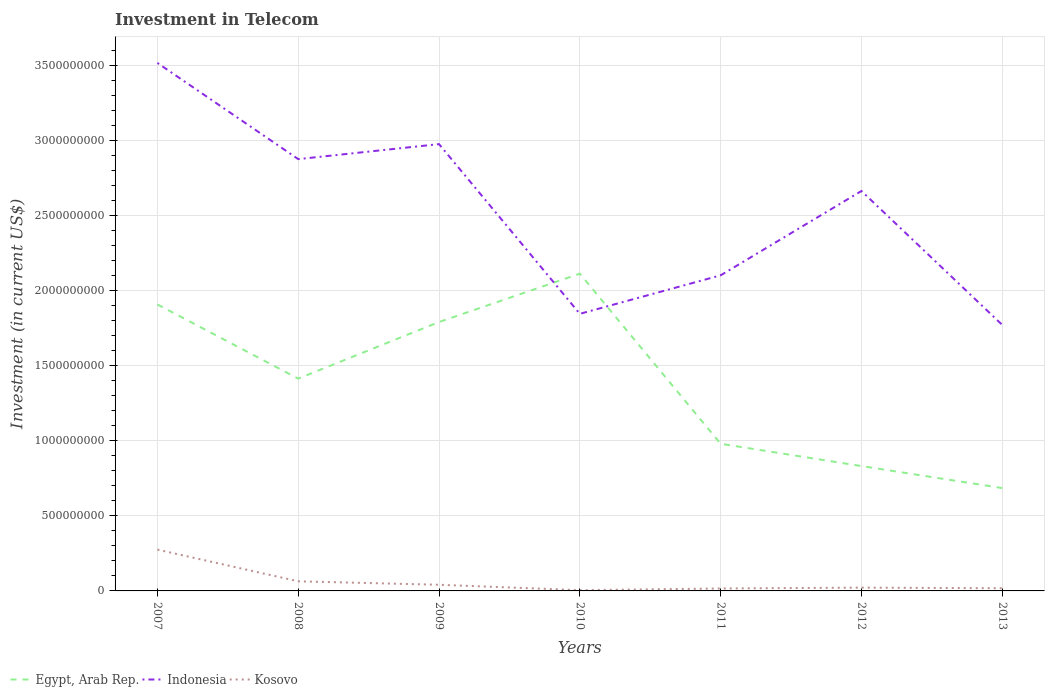Does the line corresponding to Egypt, Arab Rep. intersect with the line corresponding to Indonesia?
Ensure brevity in your answer.  Yes. Is the number of lines equal to the number of legend labels?
Provide a short and direct response. Yes. Across all years, what is the maximum amount invested in telecom in Indonesia?
Offer a very short reply. 1.77e+09. What is the total amount invested in telecom in Egypt, Arab Rep. in the graph?
Keep it short and to the point. 1.13e+09. What is the difference between the highest and the second highest amount invested in telecom in Kosovo?
Your answer should be compact. 2.70e+08. What is the difference between the highest and the lowest amount invested in telecom in Indonesia?
Provide a succinct answer. 4. How many lines are there?
Provide a short and direct response. 3. How many years are there in the graph?
Provide a succinct answer. 7. Are the values on the major ticks of Y-axis written in scientific E-notation?
Your answer should be compact. No. Does the graph contain any zero values?
Keep it short and to the point. No. Does the graph contain grids?
Offer a terse response. Yes. How are the legend labels stacked?
Your answer should be very brief. Horizontal. What is the title of the graph?
Ensure brevity in your answer.  Investment in Telecom. What is the label or title of the Y-axis?
Keep it short and to the point. Investment (in current US$). What is the Investment (in current US$) in Egypt, Arab Rep. in 2007?
Offer a very short reply. 1.91e+09. What is the Investment (in current US$) in Indonesia in 2007?
Provide a short and direct response. 3.52e+09. What is the Investment (in current US$) of Kosovo in 2007?
Ensure brevity in your answer.  2.75e+08. What is the Investment (in current US$) in Egypt, Arab Rep. in 2008?
Provide a short and direct response. 1.41e+09. What is the Investment (in current US$) of Indonesia in 2008?
Your answer should be very brief. 2.88e+09. What is the Investment (in current US$) in Kosovo in 2008?
Make the answer very short. 6.40e+07. What is the Investment (in current US$) in Egypt, Arab Rep. in 2009?
Offer a very short reply. 1.79e+09. What is the Investment (in current US$) of Indonesia in 2009?
Keep it short and to the point. 2.98e+09. What is the Investment (in current US$) of Kosovo in 2009?
Your response must be concise. 4.10e+07. What is the Investment (in current US$) in Egypt, Arab Rep. in 2010?
Ensure brevity in your answer.  2.11e+09. What is the Investment (in current US$) of Indonesia in 2010?
Give a very brief answer. 1.85e+09. What is the Investment (in current US$) of Kosovo in 2010?
Your answer should be compact. 5.10e+06. What is the Investment (in current US$) in Egypt, Arab Rep. in 2011?
Your answer should be very brief. 9.80e+08. What is the Investment (in current US$) in Indonesia in 2011?
Ensure brevity in your answer.  2.10e+09. What is the Investment (in current US$) of Kosovo in 2011?
Provide a succinct answer. 1.62e+07. What is the Investment (in current US$) in Egypt, Arab Rep. in 2012?
Keep it short and to the point. 8.32e+08. What is the Investment (in current US$) in Indonesia in 2012?
Offer a terse response. 2.66e+09. What is the Investment (in current US$) in Kosovo in 2012?
Make the answer very short. 2.20e+07. What is the Investment (in current US$) of Egypt, Arab Rep. in 2013?
Your answer should be compact. 6.85e+08. What is the Investment (in current US$) in Indonesia in 2013?
Ensure brevity in your answer.  1.77e+09. What is the Investment (in current US$) of Kosovo in 2013?
Give a very brief answer. 1.78e+07. Across all years, what is the maximum Investment (in current US$) in Egypt, Arab Rep.?
Provide a short and direct response. 2.11e+09. Across all years, what is the maximum Investment (in current US$) in Indonesia?
Provide a short and direct response. 3.52e+09. Across all years, what is the maximum Investment (in current US$) of Kosovo?
Make the answer very short. 2.75e+08. Across all years, what is the minimum Investment (in current US$) of Egypt, Arab Rep.?
Give a very brief answer. 6.85e+08. Across all years, what is the minimum Investment (in current US$) of Indonesia?
Your answer should be compact. 1.77e+09. Across all years, what is the minimum Investment (in current US$) of Kosovo?
Ensure brevity in your answer.  5.10e+06. What is the total Investment (in current US$) in Egypt, Arab Rep. in the graph?
Provide a succinct answer. 9.72e+09. What is the total Investment (in current US$) in Indonesia in the graph?
Provide a short and direct response. 1.78e+1. What is the total Investment (in current US$) of Kosovo in the graph?
Provide a short and direct response. 4.41e+08. What is the difference between the Investment (in current US$) of Egypt, Arab Rep. in 2007 and that in 2008?
Ensure brevity in your answer.  4.94e+08. What is the difference between the Investment (in current US$) of Indonesia in 2007 and that in 2008?
Your answer should be very brief. 6.41e+08. What is the difference between the Investment (in current US$) of Kosovo in 2007 and that in 2008?
Offer a very short reply. 2.11e+08. What is the difference between the Investment (in current US$) in Egypt, Arab Rep. in 2007 and that in 2009?
Your response must be concise. 1.17e+08. What is the difference between the Investment (in current US$) in Indonesia in 2007 and that in 2009?
Your response must be concise. 5.41e+08. What is the difference between the Investment (in current US$) of Kosovo in 2007 and that in 2009?
Your answer should be very brief. 2.34e+08. What is the difference between the Investment (in current US$) in Egypt, Arab Rep. in 2007 and that in 2010?
Make the answer very short. -2.05e+08. What is the difference between the Investment (in current US$) in Indonesia in 2007 and that in 2010?
Give a very brief answer. 1.67e+09. What is the difference between the Investment (in current US$) of Kosovo in 2007 and that in 2010?
Offer a terse response. 2.70e+08. What is the difference between the Investment (in current US$) of Egypt, Arab Rep. in 2007 and that in 2011?
Make the answer very short. 9.28e+08. What is the difference between the Investment (in current US$) in Indonesia in 2007 and that in 2011?
Make the answer very short. 1.41e+09. What is the difference between the Investment (in current US$) in Kosovo in 2007 and that in 2011?
Your response must be concise. 2.59e+08. What is the difference between the Investment (in current US$) of Egypt, Arab Rep. in 2007 and that in 2012?
Provide a succinct answer. 1.08e+09. What is the difference between the Investment (in current US$) of Indonesia in 2007 and that in 2012?
Provide a short and direct response. 8.53e+08. What is the difference between the Investment (in current US$) in Kosovo in 2007 and that in 2012?
Give a very brief answer. 2.53e+08. What is the difference between the Investment (in current US$) in Egypt, Arab Rep. in 2007 and that in 2013?
Offer a very short reply. 1.22e+09. What is the difference between the Investment (in current US$) in Indonesia in 2007 and that in 2013?
Provide a succinct answer. 1.74e+09. What is the difference between the Investment (in current US$) in Kosovo in 2007 and that in 2013?
Your response must be concise. 2.57e+08. What is the difference between the Investment (in current US$) of Egypt, Arab Rep. in 2008 and that in 2009?
Make the answer very short. -3.77e+08. What is the difference between the Investment (in current US$) in Indonesia in 2008 and that in 2009?
Make the answer very short. -9.99e+07. What is the difference between the Investment (in current US$) of Kosovo in 2008 and that in 2009?
Provide a short and direct response. 2.30e+07. What is the difference between the Investment (in current US$) in Egypt, Arab Rep. in 2008 and that in 2010?
Give a very brief answer. -6.99e+08. What is the difference between the Investment (in current US$) of Indonesia in 2008 and that in 2010?
Your answer should be compact. 1.03e+09. What is the difference between the Investment (in current US$) in Kosovo in 2008 and that in 2010?
Your answer should be very brief. 5.89e+07. What is the difference between the Investment (in current US$) in Egypt, Arab Rep. in 2008 and that in 2011?
Ensure brevity in your answer.  4.34e+08. What is the difference between the Investment (in current US$) in Indonesia in 2008 and that in 2011?
Offer a very short reply. 7.74e+08. What is the difference between the Investment (in current US$) of Kosovo in 2008 and that in 2011?
Ensure brevity in your answer.  4.78e+07. What is the difference between the Investment (in current US$) of Egypt, Arab Rep. in 2008 and that in 2012?
Your answer should be very brief. 5.82e+08. What is the difference between the Investment (in current US$) in Indonesia in 2008 and that in 2012?
Keep it short and to the point. 2.12e+08. What is the difference between the Investment (in current US$) of Kosovo in 2008 and that in 2012?
Offer a very short reply. 4.20e+07. What is the difference between the Investment (in current US$) in Egypt, Arab Rep. in 2008 and that in 2013?
Make the answer very short. 7.29e+08. What is the difference between the Investment (in current US$) of Indonesia in 2008 and that in 2013?
Your response must be concise. 1.10e+09. What is the difference between the Investment (in current US$) in Kosovo in 2008 and that in 2013?
Ensure brevity in your answer.  4.62e+07. What is the difference between the Investment (in current US$) in Egypt, Arab Rep. in 2009 and that in 2010?
Provide a short and direct response. -3.22e+08. What is the difference between the Investment (in current US$) in Indonesia in 2009 and that in 2010?
Keep it short and to the point. 1.13e+09. What is the difference between the Investment (in current US$) in Kosovo in 2009 and that in 2010?
Provide a short and direct response. 3.59e+07. What is the difference between the Investment (in current US$) in Egypt, Arab Rep. in 2009 and that in 2011?
Provide a short and direct response. 8.11e+08. What is the difference between the Investment (in current US$) of Indonesia in 2009 and that in 2011?
Ensure brevity in your answer.  8.74e+08. What is the difference between the Investment (in current US$) of Kosovo in 2009 and that in 2011?
Offer a very short reply. 2.48e+07. What is the difference between the Investment (in current US$) in Egypt, Arab Rep. in 2009 and that in 2012?
Ensure brevity in your answer.  9.59e+08. What is the difference between the Investment (in current US$) of Indonesia in 2009 and that in 2012?
Keep it short and to the point. 3.12e+08. What is the difference between the Investment (in current US$) in Kosovo in 2009 and that in 2012?
Provide a short and direct response. 1.90e+07. What is the difference between the Investment (in current US$) in Egypt, Arab Rep. in 2009 and that in 2013?
Keep it short and to the point. 1.11e+09. What is the difference between the Investment (in current US$) of Indonesia in 2009 and that in 2013?
Keep it short and to the point. 1.20e+09. What is the difference between the Investment (in current US$) in Kosovo in 2009 and that in 2013?
Ensure brevity in your answer.  2.32e+07. What is the difference between the Investment (in current US$) of Egypt, Arab Rep. in 2010 and that in 2011?
Keep it short and to the point. 1.13e+09. What is the difference between the Investment (in current US$) of Indonesia in 2010 and that in 2011?
Provide a short and direct response. -2.56e+08. What is the difference between the Investment (in current US$) of Kosovo in 2010 and that in 2011?
Ensure brevity in your answer.  -1.11e+07. What is the difference between the Investment (in current US$) of Egypt, Arab Rep. in 2010 and that in 2012?
Keep it short and to the point. 1.28e+09. What is the difference between the Investment (in current US$) in Indonesia in 2010 and that in 2012?
Your answer should be very brief. -8.18e+08. What is the difference between the Investment (in current US$) of Kosovo in 2010 and that in 2012?
Offer a terse response. -1.69e+07. What is the difference between the Investment (in current US$) in Egypt, Arab Rep. in 2010 and that in 2013?
Your answer should be very brief. 1.43e+09. What is the difference between the Investment (in current US$) in Indonesia in 2010 and that in 2013?
Provide a short and direct response. 7.40e+07. What is the difference between the Investment (in current US$) of Kosovo in 2010 and that in 2013?
Make the answer very short. -1.27e+07. What is the difference between the Investment (in current US$) of Egypt, Arab Rep. in 2011 and that in 2012?
Your response must be concise. 1.48e+08. What is the difference between the Investment (in current US$) of Indonesia in 2011 and that in 2012?
Offer a very short reply. -5.62e+08. What is the difference between the Investment (in current US$) of Kosovo in 2011 and that in 2012?
Make the answer very short. -5.80e+06. What is the difference between the Investment (in current US$) in Egypt, Arab Rep. in 2011 and that in 2013?
Your answer should be compact. 2.95e+08. What is the difference between the Investment (in current US$) of Indonesia in 2011 and that in 2013?
Offer a terse response. 3.30e+08. What is the difference between the Investment (in current US$) of Kosovo in 2011 and that in 2013?
Provide a succinct answer. -1.60e+06. What is the difference between the Investment (in current US$) of Egypt, Arab Rep. in 2012 and that in 2013?
Offer a very short reply. 1.47e+08. What is the difference between the Investment (in current US$) of Indonesia in 2012 and that in 2013?
Make the answer very short. 8.92e+08. What is the difference between the Investment (in current US$) of Kosovo in 2012 and that in 2013?
Your answer should be very brief. 4.20e+06. What is the difference between the Investment (in current US$) in Egypt, Arab Rep. in 2007 and the Investment (in current US$) in Indonesia in 2008?
Keep it short and to the point. -9.68e+08. What is the difference between the Investment (in current US$) of Egypt, Arab Rep. in 2007 and the Investment (in current US$) of Kosovo in 2008?
Your response must be concise. 1.84e+09. What is the difference between the Investment (in current US$) of Indonesia in 2007 and the Investment (in current US$) of Kosovo in 2008?
Your response must be concise. 3.45e+09. What is the difference between the Investment (in current US$) in Egypt, Arab Rep. in 2007 and the Investment (in current US$) in Indonesia in 2009?
Provide a short and direct response. -1.07e+09. What is the difference between the Investment (in current US$) in Egypt, Arab Rep. in 2007 and the Investment (in current US$) in Kosovo in 2009?
Offer a very short reply. 1.87e+09. What is the difference between the Investment (in current US$) of Indonesia in 2007 and the Investment (in current US$) of Kosovo in 2009?
Provide a succinct answer. 3.48e+09. What is the difference between the Investment (in current US$) in Egypt, Arab Rep. in 2007 and the Investment (in current US$) in Indonesia in 2010?
Make the answer very short. 6.24e+07. What is the difference between the Investment (in current US$) in Egypt, Arab Rep. in 2007 and the Investment (in current US$) in Kosovo in 2010?
Offer a terse response. 1.90e+09. What is the difference between the Investment (in current US$) of Indonesia in 2007 and the Investment (in current US$) of Kosovo in 2010?
Provide a short and direct response. 3.51e+09. What is the difference between the Investment (in current US$) in Egypt, Arab Rep. in 2007 and the Investment (in current US$) in Indonesia in 2011?
Make the answer very short. -1.94e+08. What is the difference between the Investment (in current US$) of Egypt, Arab Rep. in 2007 and the Investment (in current US$) of Kosovo in 2011?
Give a very brief answer. 1.89e+09. What is the difference between the Investment (in current US$) of Indonesia in 2007 and the Investment (in current US$) of Kosovo in 2011?
Your answer should be very brief. 3.50e+09. What is the difference between the Investment (in current US$) in Egypt, Arab Rep. in 2007 and the Investment (in current US$) in Indonesia in 2012?
Give a very brief answer. -7.56e+08. What is the difference between the Investment (in current US$) in Egypt, Arab Rep. in 2007 and the Investment (in current US$) in Kosovo in 2012?
Your response must be concise. 1.89e+09. What is the difference between the Investment (in current US$) of Indonesia in 2007 and the Investment (in current US$) of Kosovo in 2012?
Provide a short and direct response. 3.49e+09. What is the difference between the Investment (in current US$) of Egypt, Arab Rep. in 2007 and the Investment (in current US$) of Indonesia in 2013?
Give a very brief answer. 1.36e+08. What is the difference between the Investment (in current US$) of Egypt, Arab Rep. in 2007 and the Investment (in current US$) of Kosovo in 2013?
Your answer should be very brief. 1.89e+09. What is the difference between the Investment (in current US$) in Indonesia in 2007 and the Investment (in current US$) in Kosovo in 2013?
Your answer should be very brief. 3.50e+09. What is the difference between the Investment (in current US$) of Egypt, Arab Rep. in 2008 and the Investment (in current US$) of Indonesia in 2009?
Offer a terse response. -1.56e+09. What is the difference between the Investment (in current US$) of Egypt, Arab Rep. in 2008 and the Investment (in current US$) of Kosovo in 2009?
Make the answer very short. 1.37e+09. What is the difference between the Investment (in current US$) of Indonesia in 2008 and the Investment (in current US$) of Kosovo in 2009?
Make the answer very short. 2.84e+09. What is the difference between the Investment (in current US$) of Egypt, Arab Rep. in 2008 and the Investment (in current US$) of Indonesia in 2010?
Provide a short and direct response. -4.32e+08. What is the difference between the Investment (in current US$) in Egypt, Arab Rep. in 2008 and the Investment (in current US$) in Kosovo in 2010?
Offer a terse response. 1.41e+09. What is the difference between the Investment (in current US$) in Indonesia in 2008 and the Investment (in current US$) in Kosovo in 2010?
Provide a short and direct response. 2.87e+09. What is the difference between the Investment (in current US$) of Egypt, Arab Rep. in 2008 and the Investment (in current US$) of Indonesia in 2011?
Offer a very short reply. -6.88e+08. What is the difference between the Investment (in current US$) in Egypt, Arab Rep. in 2008 and the Investment (in current US$) in Kosovo in 2011?
Your answer should be very brief. 1.40e+09. What is the difference between the Investment (in current US$) of Indonesia in 2008 and the Investment (in current US$) of Kosovo in 2011?
Make the answer very short. 2.86e+09. What is the difference between the Investment (in current US$) of Egypt, Arab Rep. in 2008 and the Investment (in current US$) of Indonesia in 2012?
Your response must be concise. -1.25e+09. What is the difference between the Investment (in current US$) of Egypt, Arab Rep. in 2008 and the Investment (in current US$) of Kosovo in 2012?
Provide a short and direct response. 1.39e+09. What is the difference between the Investment (in current US$) of Indonesia in 2008 and the Investment (in current US$) of Kosovo in 2012?
Ensure brevity in your answer.  2.85e+09. What is the difference between the Investment (in current US$) of Egypt, Arab Rep. in 2008 and the Investment (in current US$) of Indonesia in 2013?
Your answer should be compact. -3.58e+08. What is the difference between the Investment (in current US$) in Egypt, Arab Rep. in 2008 and the Investment (in current US$) in Kosovo in 2013?
Ensure brevity in your answer.  1.40e+09. What is the difference between the Investment (in current US$) of Indonesia in 2008 and the Investment (in current US$) of Kosovo in 2013?
Your answer should be very brief. 2.86e+09. What is the difference between the Investment (in current US$) of Egypt, Arab Rep. in 2009 and the Investment (in current US$) of Indonesia in 2010?
Offer a very short reply. -5.46e+07. What is the difference between the Investment (in current US$) in Egypt, Arab Rep. in 2009 and the Investment (in current US$) in Kosovo in 2010?
Provide a succinct answer. 1.79e+09. What is the difference between the Investment (in current US$) in Indonesia in 2009 and the Investment (in current US$) in Kosovo in 2010?
Your answer should be very brief. 2.97e+09. What is the difference between the Investment (in current US$) in Egypt, Arab Rep. in 2009 and the Investment (in current US$) in Indonesia in 2011?
Provide a succinct answer. -3.11e+08. What is the difference between the Investment (in current US$) in Egypt, Arab Rep. in 2009 and the Investment (in current US$) in Kosovo in 2011?
Provide a succinct answer. 1.77e+09. What is the difference between the Investment (in current US$) in Indonesia in 2009 and the Investment (in current US$) in Kosovo in 2011?
Offer a terse response. 2.96e+09. What is the difference between the Investment (in current US$) of Egypt, Arab Rep. in 2009 and the Investment (in current US$) of Indonesia in 2012?
Provide a succinct answer. -8.73e+08. What is the difference between the Investment (in current US$) of Egypt, Arab Rep. in 2009 and the Investment (in current US$) of Kosovo in 2012?
Give a very brief answer. 1.77e+09. What is the difference between the Investment (in current US$) in Indonesia in 2009 and the Investment (in current US$) in Kosovo in 2012?
Provide a succinct answer. 2.95e+09. What is the difference between the Investment (in current US$) in Egypt, Arab Rep. in 2009 and the Investment (in current US$) in Indonesia in 2013?
Ensure brevity in your answer.  1.94e+07. What is the difference between the Investment (in current US$) of Egypt, Arab Rep. in 2009 and the Investment (in current US$) of Kosovo in 2013?
Your answer should be compact. 1.77e+09. What is the difference between the Investment (in current US$) in Indonesia in 2009 and the Investment (in current US$) in Kosovo in 2013?
Make the answer very short. 2.96e+09. What is the difference between the Investment (in current US$) in Egypt, Arab Rep. in 2010 and the Investment (in current US$) in Indonesia in 2011?
Your answer should be compact. 1.10e+07. What is the difference between the Investment (in current US$) of Egypt, Arab Rep. in 2010 and the Investment (in current US$) of Kosovo in 2011?
Provide a succinct answer. 2.10e+09. What is the difference between the Investment (in current US$) in Indonesia in 2010 and the Investment (in current US$) in Kosovo in 2011?
Your answer should be very brief. 1.83e+09. What is the difference between the Investment (in current US$) of Egypt, Arab Rep. in 2010 and the Investment (in current US$) of Indonesia in 2012?
Make the answer very short. -5.51e+08. What is the difference between the Investment (in current US$) of Egypt, Arab Rep. in 2010 and the Investment (in current US$) of Kosovo in 2012?
Your response must be concise. 2.09e+09. What is the difference between the Investment (in current US$) of Indonesia in 2010 and the Investment (in current US$) of Kosovo in 2012?
Give a very brief answer. 1.82e+09. What is the difference between the Investment (in current US$) in Egypt, Arab Rep. in 2010 and the Investment (in current US$) in Indonesia in 2013?
Ensure brevity in your answer.  3.41e+08. What is the difference between the Investment (in current US$) of Egypt, Arab Rep. in 2010 and the Investment (in current US$) of Kosovo in 2013?
Your answer should be compact. 2.10e+09. What is the difference between the Investment (in current US$) in Indonesia in 2010 and the Investment (in current US$) in Kosovo in 2013?
Offer a very short reply. 1.83e+09. What is the difference between the Investment (in current US$) of Egypt, Arab Rep. in 2011 and the Investment (in current US$) of Indonesia in 2012?
Ensure brevity in your answer.  -1.68e+09. What is the difference between the Investment (in current US$) in Egypt, Arab Rep. in 2011 and the Investment (in current US$) in Kosovo in 2012?
Offer a very short reply. 9.58e+08. What is the difference between the Investment (in current US$) of Indonesia in 2011 and the Investment (in current US$) of Kosovo in 2012?
Offer a terse response. 2.08e+09. What is the difference between the Investment (in current US$) in Egypt, Arab Rep. in 2011 and the Investment (in current US$) in Indonesia in 2013?
Ensure brevity in your answer.  -7.92e+08. What is the difference between the Investment (in current US$) of Egypt, Arab Rep. in 2011 and the Investment (in current US$) of Kosovo in 2013?
Your answer should be compact. 9.62e+08. What is the difference between the Investment (in current US$) in Indonesia in 2011 and the Investment (in current US$) in Kosovo in 2013?
Your answer should be very brief. 2.08e+09. What is the difference between the Investment (in current US$) of Egypt, Arab Rep. in 2012 and the Investment (in current US$) of Indonesia in 2013?
Make the answer very short. -9.40e+08. What is the difference between the Investment (in current US$) of Egypt, Arab Rep. in 2012 and the Investment (in current US$) of Kosovo in 2013?
Your answer should be very brief. 8.14e+08. What is the difference between the Investment (in current US$) in Indonesia in 2012 and the Investment (in current US$) in Kosovo in 2013?
Your answer should be very brief. 2.65e+09. What is the average Investment (in current US$) in Egypt, Arab Rep. per year?
Give a very brief answer. 1.39e+09. What is the average Investment (in current US$) in Indonesia per year?
Offer a terse response. 2.54e+09. What is the average Investment (in current US$) in Kosovo per year?
Offer a very short reply. 6.30e+07. In the year 2007, what is the difference between the Investment (in current US$) of Egypt, Arab Rep. and Investment (in current US$) of Indonesia?
Your answer should be compact. -1.61e+09. In the year 2007, what is the difference between the Investment (in current US$) in Egypt, Arab Rep. and Investment (in current US$) in Kosovo?
Provide a short and direct response. 1.63e+09. In the year 2007, what is the difference between the Investment (in current US$) in Indonesia and Investment (in current US$) in Kosovo?
Provide a short and direct response. 3.24e+09. In the year 2008, what is the difference between the Investment (in current US$) of Egypt, Arab Rep. and Investment (in current US$) of Indonesia?
Keep it short and to the point. -1.46e+09. In the year 2008, what is the difference between the Investment (in current US$) of Egypt, Arab Rep. and Investment (in current US$) of Kosovo?
Make the answer very short. 1.35e+09. In the year 2008, what is the difference between the Investment (in current US$) in Indonesia and Investment (in current US$) in Kosovo?
Offer a very short reply. 2.81e+09. In the year 2009, what is the difference between the Investment (in current US$) of Egypt, Arab Rep. and Investment (in current US$) of Indonesia?
Your answer should be compact. -1.18e+09. In the year 2009, what is the difference between the Investment (in current US$) of Egypt, Arab Rep. and Investment (in current US$) of Kosovo?
Make the answer very short. 1.75e+09. In the year 2009, what is the difference between the Investment (in current US$) of Indonesia and Investment (in current US$) of Kosovo?
Make the answer very short. 2.93e+09. In the year 2010, what is the difference between the Investment (in current US$) of Egypt, Arab Rep. and Investment (in current US$) of Indonesia?
Keep it short and to the point. 2.67e+08. In the year 2010, what is the difference between the Investment (in current US$) of Egypt, Arab Rep. and Investment (in current US$) of Kosovo?
Offer a very short reply. 2.11e+09. In the year 2010, what is the difference between the Investment (in current US$) of Indonesia and Investment (in current US$) of Kosovo?
Provide a succinct answer. 1.84e+09. In the year 2011, what is the difference between the Investment (in current US$) of Egypt, Arab Rep. and Investment (in current US$) of Indonesia?
Offer a very short reply. -1.12e+09. In the year 2011, what is the difference between the Investment (in current US$) of Egypt, Arab Rep. and Investment (in current US$) of Kosovo?
Offer a very short reply. 9.64e+08. In the year 2011, what is the difference between the Investment (in current US$) in Indonesia and Investment (in current US$) in Kosovo?
Provide a succinct answer. 2.09e+09. In the year 2012, what is the difference between the Investment (in current US$) of Egypt, Arab Rep. and Investment (in current US$) of Indonesia?
Give a very brief answer. -1.83e+09. In the year 2012, what is the difference between the Investment (in current US$) in Egypt, Arab Rep. and Investment (in current US$) in Kosovo?
Your response must be concise. 8.10e+08. In the year 2012, what is the difference between the Investment (in current US$) of Indonesia and Investment (in current US$) of Kosovo?
Your response must be concise. 2.64e+09. In the year 2013, what is the difference between the Investment (in current US$) of Egypt, Arab Rep. and Investment (in current US$) of Indonesia?
Your answer should be compact. -1.09e+09. In the year 2013, what is the difference between the Investment (in current US$) of Egypt, Arab Rep. and Investment (in current US$) of Kosovo?
Your answer should be compact. 6.67e+08. In the year 2013, what is the difference between the Investment (in current US$) of Indonesia and Investment (in current US$) of Kosovo?
Offer a very short reply. 1.75e+09. What is the ratio of the Investment (in current US$) in Egypt, Arab Rep. in 2007 to that in 2008?
Ensure brevity in your answer.  1.35. What is the ratio of the Investment (in current US$) of Indonesia in 2007 to that in 2008?
Your response must be concise. 1.22. What is the ratio of the Investment (in current US$) in Kosovo in 2007 to that in 2008?
Make the answer very short. 4.3. What is the ratio of the Investment (in current US$) in Egypt, Arab Rep. in 2007 to that in 2009?
Offer a very short reply. 1.07. What is the ratio of the Investment (in current US$) in Indonesia in 2007 to that in 2009?
Your response must be concise. 1.18. What is the ratio of the Investment (in current US$) of Kosovo in 2007 to that in 2009?
Your response must be concise. 6.71. What is the ratio of the Investment (in current US$) in Egypt, Arab Rep. in 2007 to that in 2010?
Offer a terse response. 0.9. What is the ratio of the Investment (in current US$) in Indonesia in 2007 to that in 2010?
Keep it short and to the point. 1.91. What is the ratio of the Investment (in current US$) of Kosovo in 2007 to that in 2010?
Offer a very short reply. 53.92. What is the ratio of the Investment (in current US$) in Egypt, Arab Rep. in 2007 to that in 2011?
Ensure brevity in your answer.  1.95. What is the ratio of the Investment (in current US$) of Indonesia in 2007 to that in 2011?
Your answer should be compact. 1.67. What is the ratio of the Investment (in current US$) of Kosovo in 2007 to that in 2011?
Make the answer very short. 16.98. What is the ratio of the Investment (in current US$) of Egypt, Arab Rep. in 2007 to that in 2012?
Your answer should be compact. 2.29. What is the ratio of the Investment (in current US$) of Indonesia in 2007 to that in 2012?
Provide a succinct answer. 1.32. What is the ratio of the Investment (in current US$) of Egypt, Arab Rep. in 2007 to that in 2013?
Give a very brief answer. 2.79. What is the ratio of the Investment (in current US$) of Indonesia in 2007 to that in 2013?
Keep it short and to the point. 1.99. What is the ratio of the Investment (in current US$) of Kosovo in 2007 to that in 2013?
Offer a very short reply. 15.45. What is the ratio of the Investment (in current US$) of Egypt, Arab Rep. in 2008 to that in 2009?
Give a very brief answer. 0.79. What is the ratio of the Investment (in current US$) of Indonesia in 2008 to that in 2009?
Your answer should be very brief. 0.97. What is the ratio of the Investment (in current US$) in Kosovo in 2008 to that in 2009?
Make the answer very short. 1.56. What is the ratio of the Investment (in current US$) of Egypt, Arab Rep. in 2008 to that in 2010?
Your response must be concise. 0.67. What is the ratio of the Investment (in current US$) of Indonesia in 2008 to that in 2010?
Keep it short and to the point. 1.56. What is the ratio of the Investment (in current US$) in Kosovo in 2008 to that in 2010?
Offer a very short reply. 12.55. What is the ratio of the Investment (in current US$) in Egypt, Arab Rep. in 2008 to that in 2011?
Provide a succinct answer. 1.44. What is the ratio of the Investment (in current US$) in Indonesia in 2008 to that in 2011?
Provide a succinct answer. 1.37. What is the ratio of the Investment (in current US$) in Kosovo in 2008 to that in 2011?
Your answer should be compact. 3.95. What is the ratio of the Investment (in current US$) in Egypt, Arab Rep. in 2008 to that in 2012?
Offer a terse response. 1.7. What is the ratio of the Investment (in current US$) of Indonesia in 2008 to that in 2012?
Make the answer very short. 1.08. What is the ratio of the Investment (in current US$) in Kosovo in 2008 to that in 2012?
Your response must be concise. 2.91. What is the ratio of the Investment (in current US$) of Egypt, Arab Rep. in 2008 to that in 2013?
Ensure brevity in your answer.  2.06. What is the ratio of the Investment (in current US$) in Indonesia in 2008 to that in 2013?
Make the answer very short. 1.62. What is the ratio of the Investment (in current US$) in Kosovo in 2008 to that in 2013?
Provide a short and direct response. 3.6. What is the ratio of the Investment (in current US$) of Egypt, Arab Rep. in 2009 to that in 2010?
Offer a terse response. 0.85. What is the ratio of the Investment (in current US$) of Indonesia in 2009 to that in 2010?
Your response must be concise. 1.61. What is the ratio of the Investment (in current US$) in Kosovo in 2009 to that in 2010?
Provide a succinct answer. 8.04. What is the ratio of the Investment (in current US$) in Egypt, Arab Rep. in 2009 to that in 2011?
Provide a succinct answer. 1.83. What is the ratio of the Investment (in current US$) in Indonesia in 2009 to that in 2011?
Give a very brief answer. 1.42. What is the ratio of the Investment (in current US$) in Kosovo in 2009 to that in 2011?
Provide a succinct answer. 2.53. What is the ratio of the Investment (in current US$) in Egypt, Arab Rep. in 2009 to that in 2012?
Provide a succinct answer. 2.15. What is the ratio of the Investment (in current US$) of Indonesia in 2009 to that in 2012?
Provide a short and direct response. 1.12. What is the ratio of the Investment (in current US$) in Kosovo in 2009 to that in 2012?
Provide a short and direct response. 1.86. What is the ratio of the Investment (in current US$) of Egypt, Arab Rep. in 2009 to that in 2013?
Keep it short and to the point. 2.61. What is the ratio of the Investment (in current US$) of Indonesia in 2009 to that in 2013?
Offer a very short reply. 1.68. What is the ratio of the Investment (in current US$) in Kosovo in 2009 to that in 2013?
Your answer should be compact. 2.3. What is the ratio of the Investment (in current US$) in Egypt, Arab Rep. in 2010 to that in 2011?
Offer a very short reply. 2.16. What is the ratio of the Investment (in current US$) in Indonesia in 2010 to that in 2011?
Give a very brief answer. 0.88. What is the ratio of the Investment (in current US$) in Kosovo in 2010 to that in 2011?
Your response must be concise. 0.31. What is the ratio of the Investment (in current US$) in Egypt, Arab Rep. in 2010 to that in 2012?
Offer a terse response. 2.54. What is the ratio of the Investment (in current US$) in Indonesia in 2010 to that in 2012?
Provide a succinct answer. 0.69. What is the ratio of the Investment (in current US$) in Kosovo in 2010 to that in 2012?
Make the answer very short. 0.23. What is the ratio of the Investment (in current US$) in Egypt, Arab Rep. in 2010 to that in 2013?
Give a very brief answer. 3.08. What is the ratio of the Investment (in current US$) in Indonesia in 2010 to that in 2013?
Provide a succinct answer. 1.04. What is the ratio of the Investment (in current US$) of Kosovo in 2010 to that in 2013?
Your response must be concise. 0.29. What is the ratio of the Investment (in current US$) in Egypt, Arab Rep. in 2011 to that in 2012?
Ensure brevity in your answer.  1.18. What is the ratio of the Investment (in current US$) of Indonesia in 2011 to that in 2012?
Give a very brief answer. 0.79. What is the ratio of the Investment (in current US$) of Kosovo in 2011 to that in 2012?
Keep it short and to the point. 0.74. What is the ratio of the Investment (in current US$) in Egypt, Arab Rep. in 2011 to that in 2013?
Give a very brief answer. 1.43. What is the ratio of the Investment (in current US$) of Indonesia in 2011 to that in 2013?
Your response must be concise. 1.19. What is the ratio of the Investment (in current US$) in Kosovo in 2011 to that in 2013?
Your answer should be very brief. 0.91. What is the ratio of the Investment (in current US$) in Egypt, Arab Rep. in 2012 to that in 2013?
Offer a very short reply. 1.21. What is the ratio of the Investment (in current US$) in Indonesia in 2012 to that in 2013?
Keep it short and to the point. 1.5. What is the ratio of the Investment (in current US$) in Kosovo in 2012 to that in 2013?
Your answer should be very brief. 1.24. What is the difference between the highest and the second highest Investment (in current US$) in Egypt, Arab Rep.?
Offer a very short reply. 2.05e+08. What is the difference between the highest and the second highest Investment (in current US$) of Indonesia?
Provide a short and direct response. 5.41e+08. What is the difference between the highest and the second highest Investment (in current US$) of Kosovo?
Offer a very short reply. 2.11e+08. What is the difference between the highest and the lowest Investment (in current US$) in Egypt, Arab Rep.?
Your response must be concise. 1.43e+09. What is the difference between the highest and the lowest Investment (in current US$) in Indonesia?
Your answer should be very brief. 1.74e+09. What is the difference between the highest and the lowest Investment (in current US$) of Kosovo?
Provide a succinct answer. 2.70e+08. 